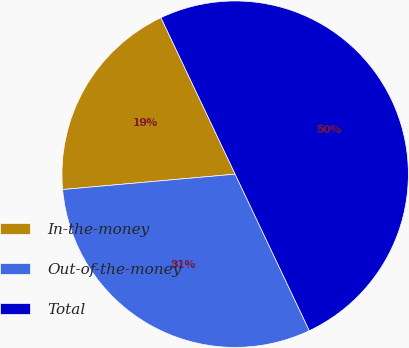Convert chart to OTSL. <chart><loc_0><loc_0><loc_500><loc_500><pie_chart><fcel>In-the-money<fcel>Out-of-the-money<fcel>Total<nl><fcel>19.37%<fcel>30.63%<fcel>50.0%<nl></chart> 